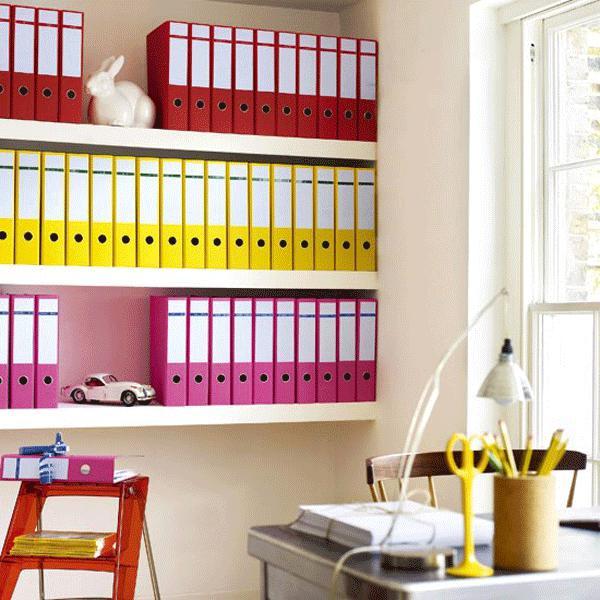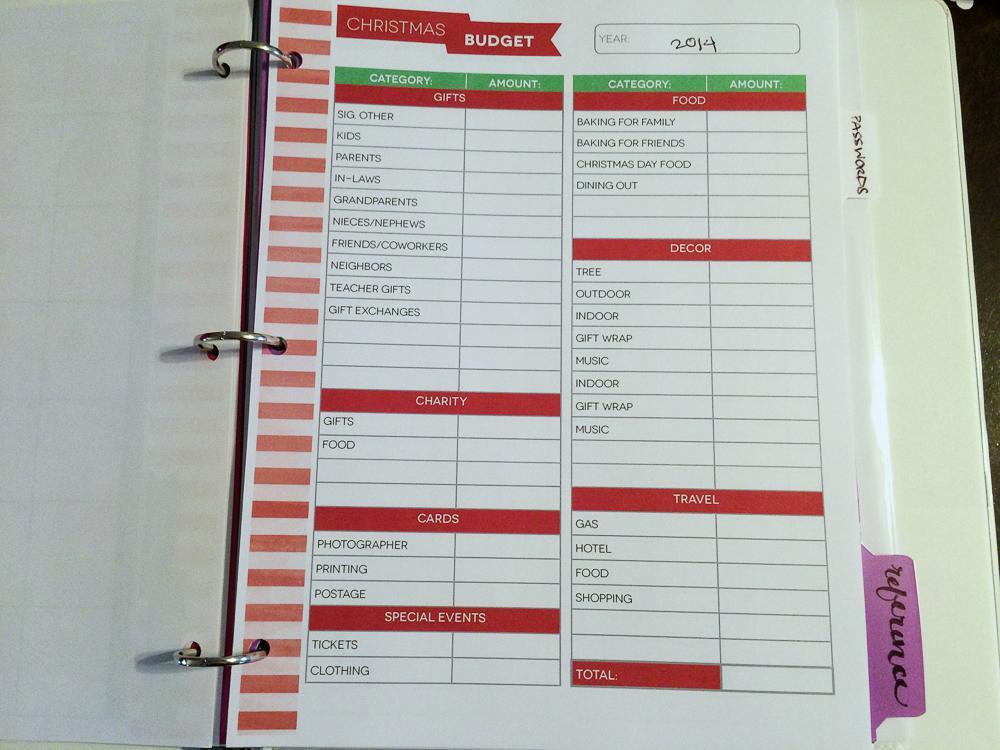The first image is the image on the left, the second image is the image on the right. Analyze the images presented: Is the assertion "There are rows of colorful binders and an open binder." valid? Answer yes or no. Yes. The first image is the image on the left, the second image is the image on the right. Assess this claim about the two images: "One image shows a wall of shelves containing vertical binders, and the other image includes at least one open binder filled with plastic-sheeted items.". Correct or not? Answer yes or no. No. 